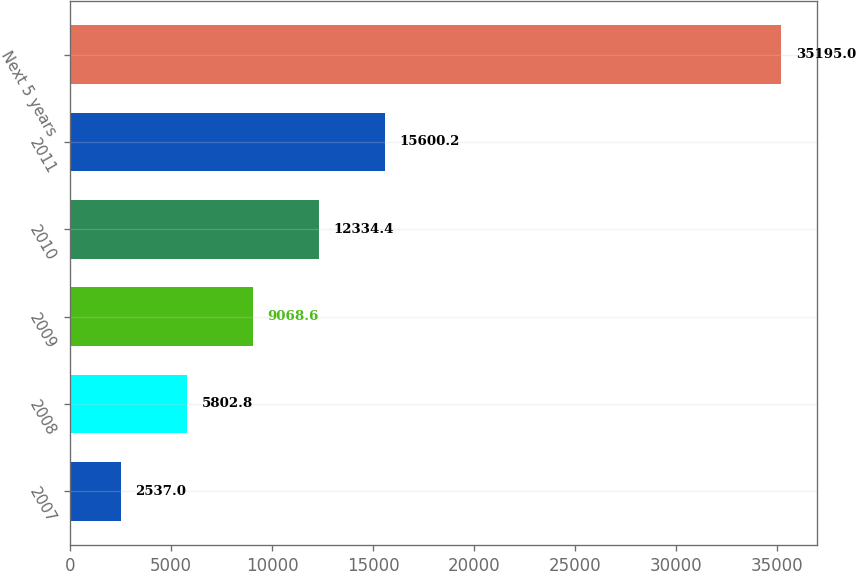Convert chart. <chart><loc_0><loc_0><loc_500><loc_500><bar_chart><fcel>2007<fcel>2008<fcel>2009<fcel>2010<fcel>2011<fcel>Next 5 years<nl><fcel>2537<fcel>5802.8<fcel>9068.6<fcel>12334.4<fcel>15600.2<fcel>35195<nl></chart> 